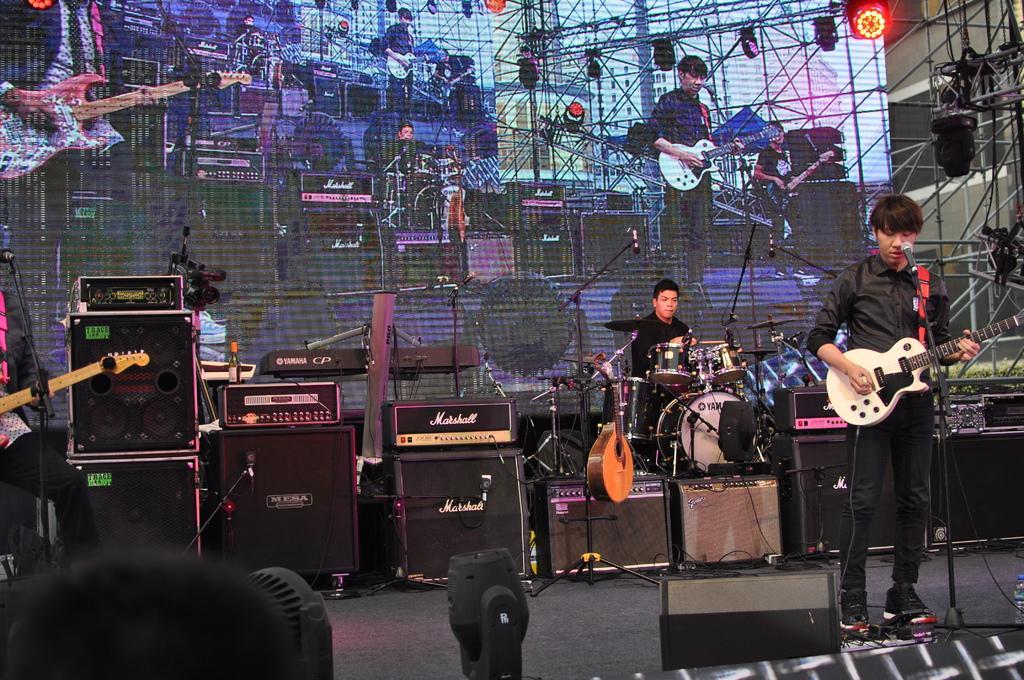How would you summarize this image in a sentence or two? here is a person standing and playing guitar. He is singing a song using a mike. At background I can see another man sitting and playing drums. This is a piano and this looks like another musical instrument. At the very left corner of the image I can see another person sitting and holding guitar. These are the speakers and some other electronic devices which are black in color. This is the screen and these are the show lights which are hanging at the top. 